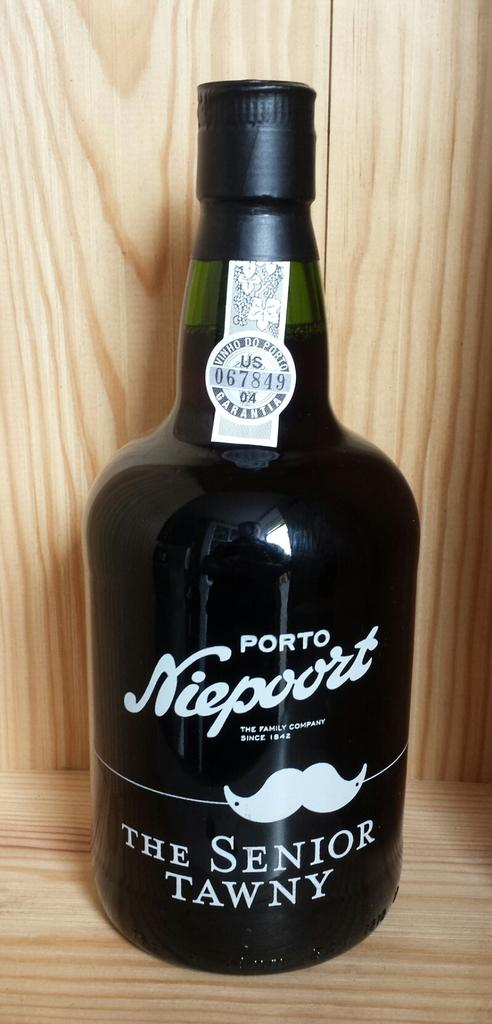What object can be seen in the image? There is a bottle in the image. Where is the bottle located? The bottle is placed on a wooden desk. What type of skin is visible on the bottle in the image? There is no skin visible on the bottle in the image, as it is an inanimate object. 